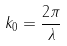Convert formula to latex. <formula><loc_0><loc_0><loc_500><loc_500>k _ { 0 } = \frac { 2 \pi } { \lambda }</formula> 